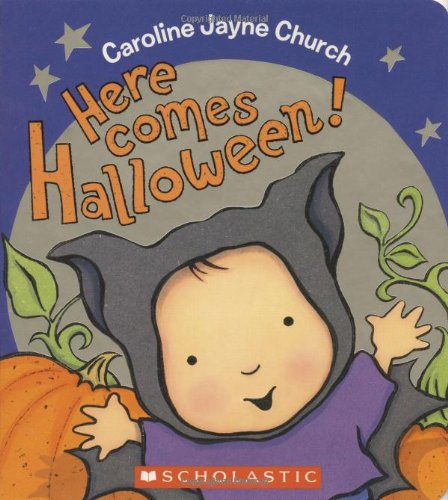Is this book related to Children's Books? Yes, this book is indeed related to Children's Books, offering age-appropriate content that stimulates the imagination and creativity of young minds. 